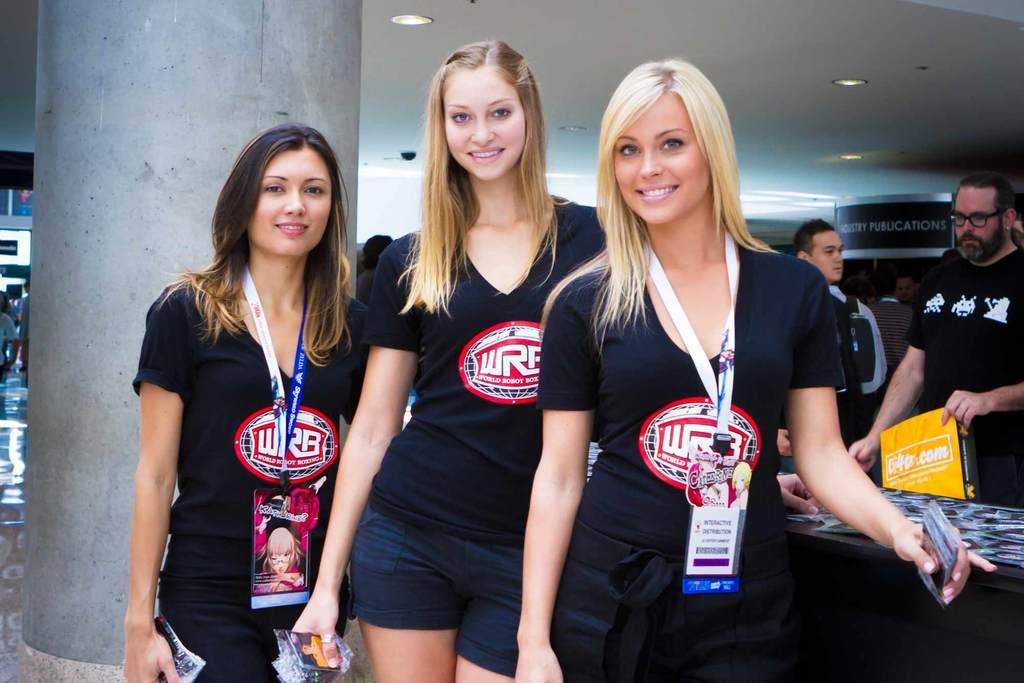<image>
Write a terse but informative summary of the picture. Three women pose for the camera and wear shirts for World Robot Boxing. 